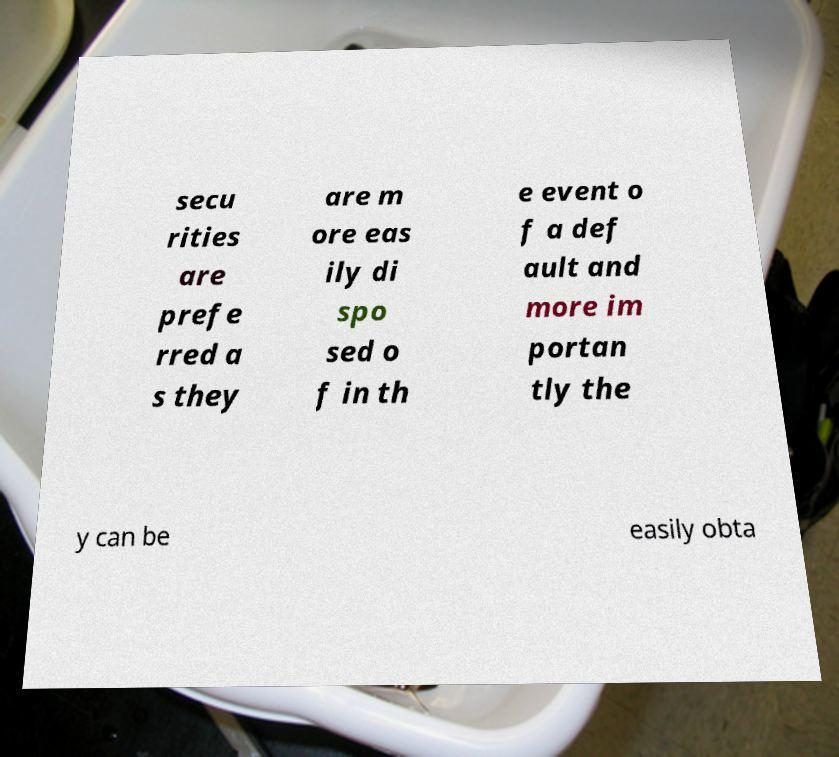There's text embedded in this image that I need extracted. Can you transcribe it verbatim? secu rities are prefe rred a s they are m ore eas ily di spo sed o f in th e event o f a def ault and more im portan tly the y can be easily obta 